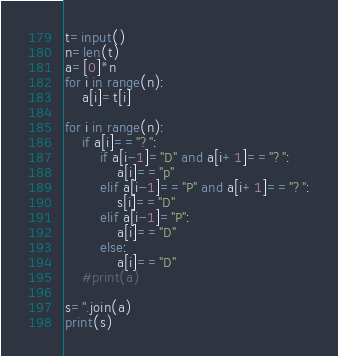<code> <loc_0><loc_0><loc_500><loc_500><_Python_>t=input()
n=len(t)
a=[0]*n
for i in range(n):
    a[i]=t[i]

for i in range(n):
    if a[i]=="?":
        if a[i-1]="D" and a[i+1]=="?":
            a[i]=="p"
        elif a[i-1]=="P" and a[i+1]=="?":
            s[i]=="D"
        elif a[i-1]="P":
            a[i]=="D"
        else:
            a[i]=="D"
    #print(a)

s=''.join(a)
print(s)
</code> 